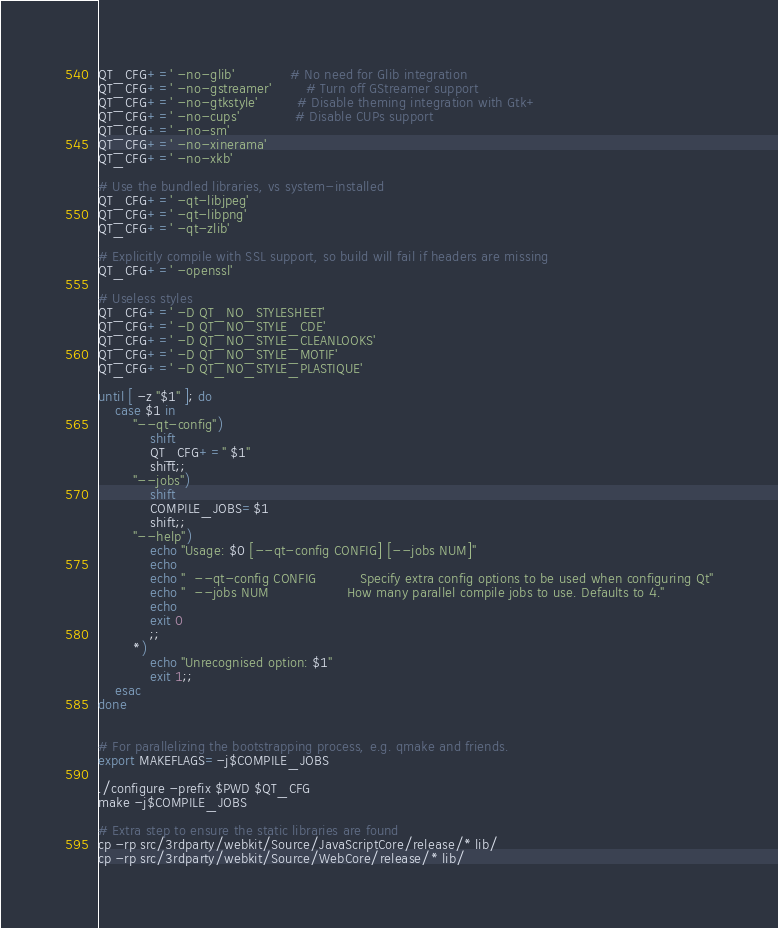<code> <loc_0><loc_0><loc_500><loc_500><_Bash_>QT_CFG+=' -no-glib'             # No need for Glib integration
QT_CFG+=' -no-gstreamer'        # Turn off GStreamer support
QT_CFG+=' -no-gtkstyle'         # Disable theming integration with Gtk+
QT_CFG+=' -no-cups'             # Disable CUPs support
QT_CFG+=' -no-sm'
QT_CFG+=' -no-xinerama'
QT_CFG+=' -no-xkb'

# Use the bundled libraries, vs system-installed
QT_CFG+=' -qt-libjpeg'
QT_CFG+=' -qt-libpng'
QT_CFG+=' -qt-zlib'

# Explicitly compile with SSL support, so build will fail if headers are missing
QT_CFG+=' -openssl'

# Useless styles
QT_CFG+=' -D QT_NO_STYLESHEET'
QT_CFG+=' -D QT_NO_STYLE_CDE'
QT_CFG+=' -D QT_NO_STYLE_CLEANLOOKS'
QT_CFG+=' -D QT_NO_STYLE_MOTIF'
QT_CFG+=' -D QT_NO_STYLE_PLASTIQUE'

until [ -z "$1" ]; do
    case $1 in
        "--qt-config")
            shift
            QT_CFG+=" $1"
            shift;;
        "--jobs")
            shift
            COMPILE_JOBS=$1
            shift;;
        "--help")
            echo "Usage: $0 [--qt-config CONFIG] [--jobs NUM]"
            echo
            echo "  --qt-config CONFIG          Specify extra config options to be used when configuring Qt"
            echo "  --jobs NUM                  How many parallel compile jobs to use. Defaults to 4."
            echo
            exit 0
            ;;
        *)
            echo "Unrecognised option: $1"
            exit 1;;
    esac
done


# For parallelizing the bootstrapping process, e.g. qmake and friends.
export MAKEFLAGS=-j$COMPILE_JOBS

./configure -prefix $PWD $QT_CFG
make -j$COMPILE_JOBS

# Extra step to ensure the static libraries are found
cp -rp src/3rdparty/webkit/Source/JavaScriptCore/release/* lib/
cp -rp src/3rdparty/webkit/Source/WebCore/release/* lib/
</code> 